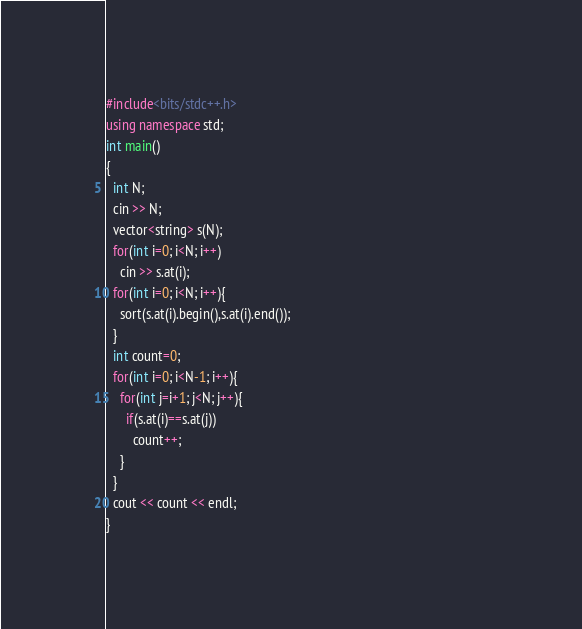Convert code to text. <code><loc_0><loc_0><loc_500><loc_500><_C++_>#include<bits/stdc++.h>                                                                          
using namespace std;
int main()
{
  int N;
  cin >> N;
  vector<string> s(N);
  for(int i=0; i<N; i++)
    cin >> s.at(i);
  for(int i=0; i<N; i++){
    sort(s.at(i).begin(),s.at(i).end());
  }
  int count=0;
  for(int i=0; i<N-1; i++){
    for(int j=i+1; j<N; j++){
      if(s.at(i)==s.at(j))
        count++;
    }
  }
  cout << count << endl;
}
</code> 